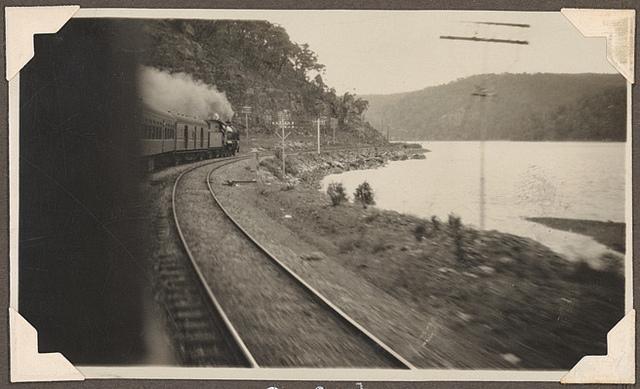How many trains could pass here at the same time?
Give a very brief answer. 2. 